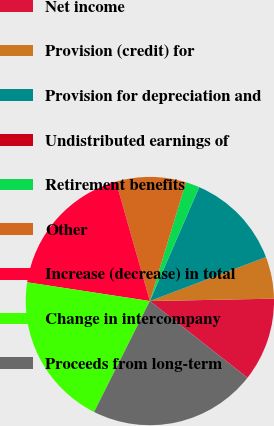<chart> <loc_0><loc_0><loc_500><loc_500><pie_chart><fcel>Net income<fcel>Provision (credit) for<fcel>Provision for depreciation and<fcel>Undistributed earnings of<fcel>Retirement benefits<fcel>Other<fcel>Increase (decrease) in total<fcel>Change in intercompany<fcel>Proceeds from long-term<nl><fcel>10.91%<fcel>5.46%<fcel>12.73%<fcel>0.0%<fcel>1.82%<fcel>9.09%<fcel>18.18%<fcel>20.0%<fcel>21.81%<nl></chart> 